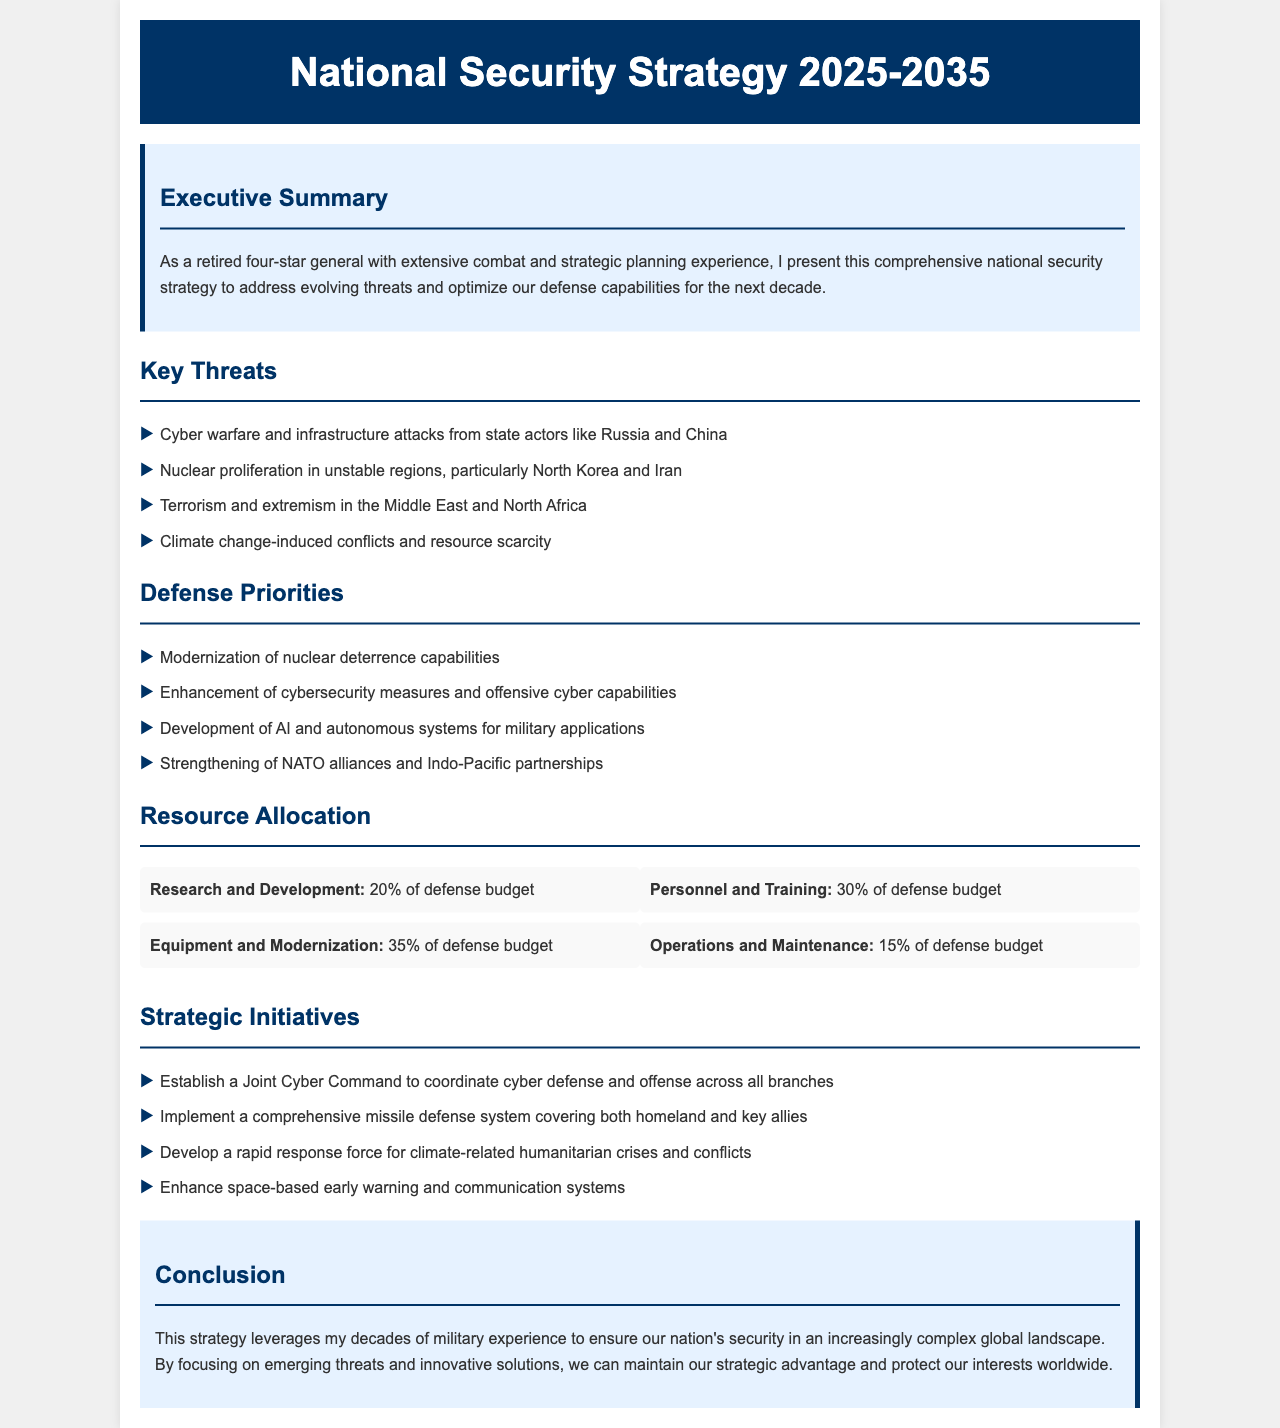What are the key threats identified in the strategy? The document lists key threats, including cyber warfare, nuclear proliferation, terrorism, and climate change-induced conflicts.
Answer: Cyber warfare and infrastructure attacks from state actors like Russia and China, nuclear proliferation in unstable regions, particularly North Korea and Iran, terrorism and extremism in the Middle East and North Africa, climate change-induced conflicts and resource scarcity What percentage of the defense budget is allocated to Equipment and Modernization? The document specifies the allocation of the defense budget across various areas, including Equipment and Modernization.
Answer: 35% What is one of the strategic initiatives mentioned in the document? The document outlines several strategic initiatives that the national security strategy aims to implement.
Answer: Establish a Joint Cyber Command to coordinate cyber defense and offense across all branches Who is the author of the national security strategy highlighted in the executive summary? The introduction identifies the author and provides context for the strategy presented in the executive summary.
Answer: A retired four-star general What are the defense priorities for the next decade? The document lists several defense priorities that need to be addressed according to the strategy.
Answer: Modernization of nuclear deterrence capabilities, enhancement of cybersecurity measures and offensive cyber capabilities, development of AI and autonomous systems for military applications, strengthening of NATO alliances and Indo-Pacific partnerships 